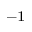<formula> <loc_0><loc_0><loc_500><loc_500>^ { - 1 }</formula> 